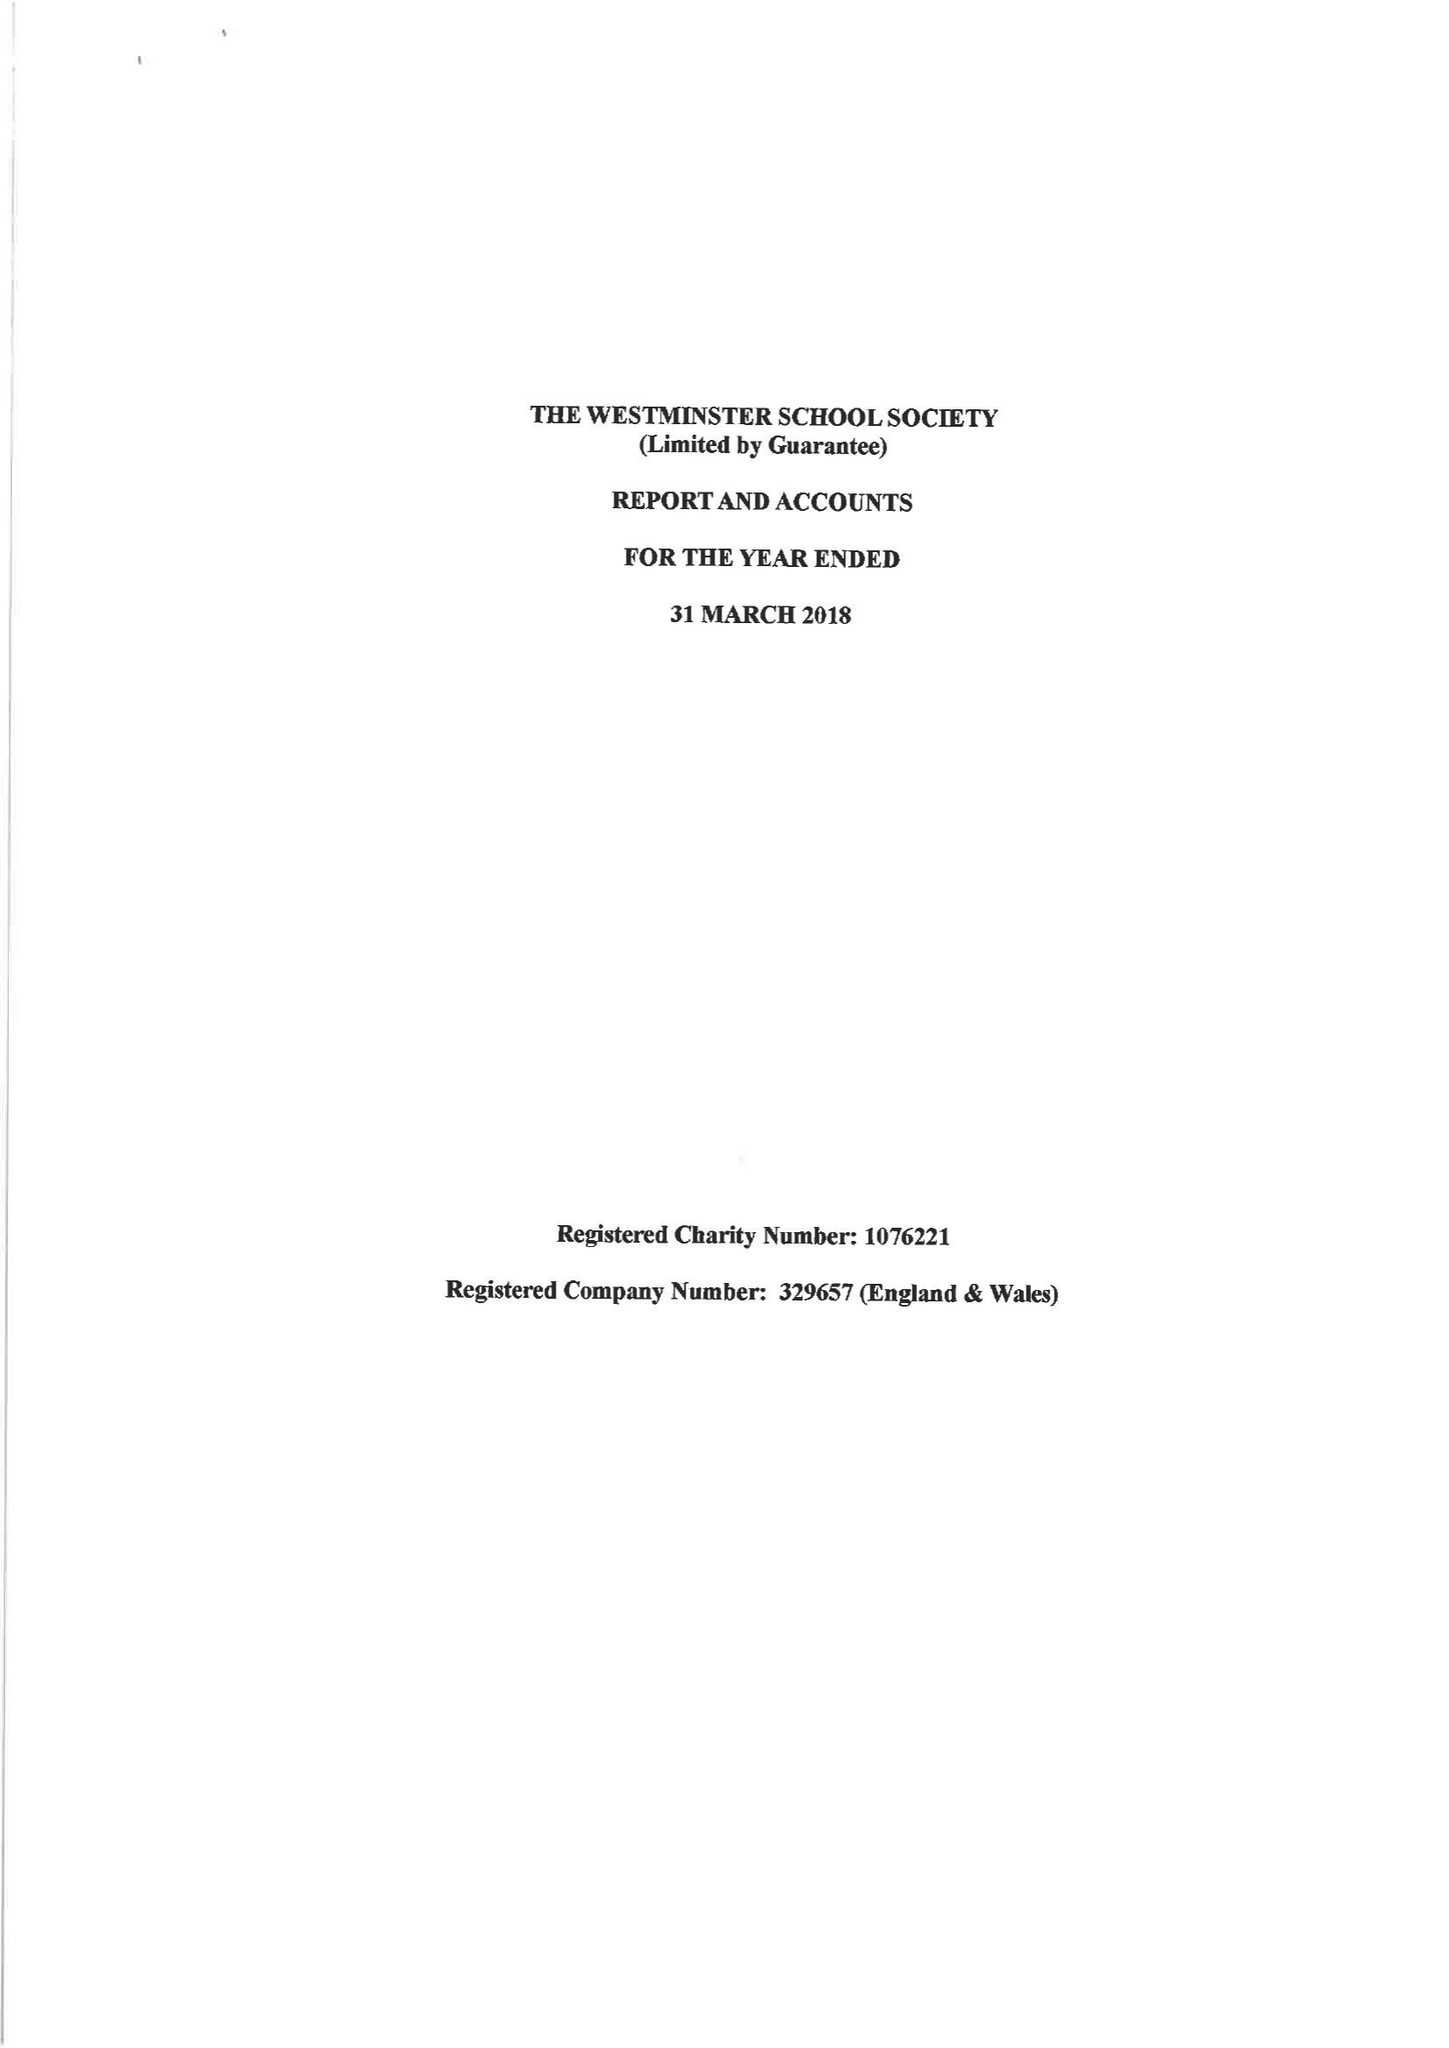What is the value for the spending_annually_in_british_pounds?
Answer the question using a single word or phrase. 204309.00 